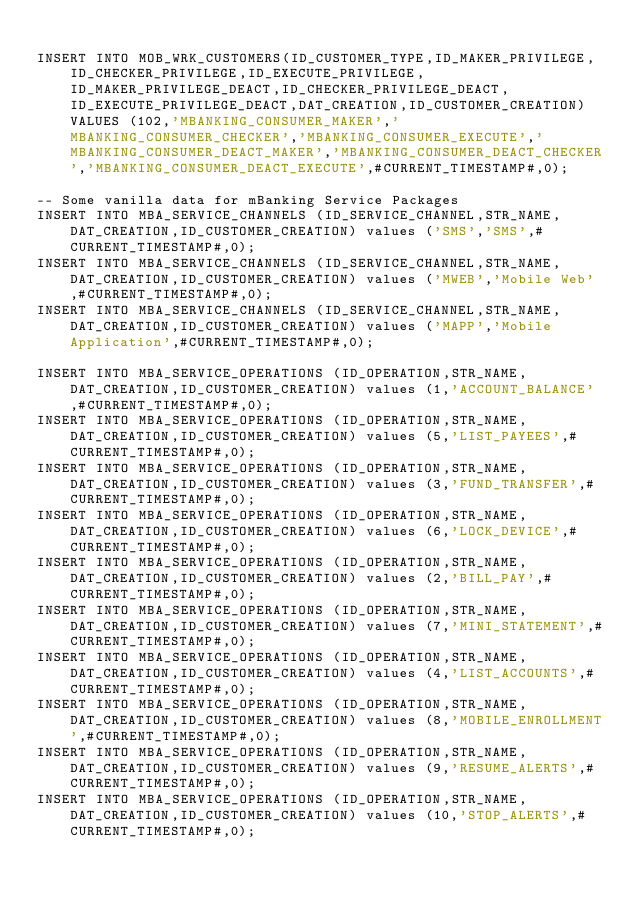Convert code to text. <code><loc_0><loc_0><loc_500><loc_500><_SQL_>
INSERT INTO MOB_WRK_CUSTOMERS(ID_CUSTOMER_TYPE,ID_MAKER_PRIVILEGE,ID_CHECKER_PRIVILEGE,ID_EXECUTE_PRIVILEGE,ID_MAKER_PRIVILEGE_DEACT,ID_CHECKER_PRIVILEGE_DEACT,ID_EXECUTE_PRIVILEGE_DEACT,DAT_CREATION,ID_CUSTOMER_CREATION) VALUES (102,'MBANKING_CONSUMER_MAKER','MBANKING_CONSUMER_CHECKER','MBANKING_CONSUMER_EXECUTE','MBANKING_CONSUMER_DEACT_MAKER','MBANKING_CONSUMER_DEACT_CHECKER','MBANKING_CONSUMER_DEACT_EXECUTE',#CURRENT_TIMESTAMP#,0);

-- Some vanilla data for mBanking Service Packages
INSERT INTO MBA_SERVICE_CHANNELS (ID_SERVICE_CHANNEL,STR_NAME,DAT_CREATION,ID_CUSTOMER_CREATION) values ('SMS','SMS',#CURRENT_TIMESTAMP#,0);
INSERT INTO MBA_SERVICE_CHANNELS (ID_SERVICE_CHANNEL,STR_NAME,DAT_CREATION,ID_CUSTOMER_CREATION) values ('MWEB','Mobile Web',#CURRENT_TIMESTAMP#,0);
INSERT INTO MBA_SERVICE_CHANNELS (ID_SERVICE_CHANNEL,STR_NAME,DAT_CREATION,ID_CUSTOMER_CREATION) values ('MAPP','Mobile Application',#CURRENT_TIMESTAMP#,0);

INSERT INTO MBA_SERVICE_OPERATIONS (ID_OPERATION,STR_NAME,DAT_CREATION,ID_CUSTOMER_CREATION) values (1,'ACCOUNT_BALANCE',#CURRENT_TIMESTAMP#,0);
INSERT INTO MBA_SERVICE_OPERATIONS (ID_OPERATION,STR_NAME,DAT_CREATION,ID_CUSTOMER_CREATION) values (5,'LIST_PAYEES',#CURRENT_TIMESTAMP#,0);
INSERT INTO MBA_SERVICE_OPERATIONS (ID_OPERATION,STR_NAME,DAT_CREATION,ID_CUSTOMER_CREATION) values (3,'FUND_TRANSFER',#CURRENT_TIMESTAMP#,0);
INSERT INTO MBA_SERVICE_OPERATIONS (ID_OPERATION,STR_NAME,DAT_CREATION,ID_CUSTOMER_CREATION) values (6,'LOCK_DEVICE',#CURRENT_TIMESTAMP#,0);
INSERT INTO MBA_SERVICE_OPERATIONS (ID_OPERATION,STR_NAME,DAT_CREATION,ID_CUSTOMER_CREATION) values (2,'BILL_PAY',#CURRENT_TIMESTAMP#,0);
INSERT INTO MBA_SERVICE_OPERATIONS (ID_OPERATION,STR_NAME,DAT_CREATION,ID_CUSTOMER_CREATION) values (7,'MINI_STATEMENT',#CURRENT_TIMESTAMP#,0);
INSERT INTO MBA_SERVICE_OPERATIONS (ID_OPERATION,STR_NAME,DAT_CREATION,ID_CUSTOMER_CREATION) values (4,'LIST_ACCOUNTS',#CURRENT_TIMESTAMP#,0);
INSERT INTO MBA_SERVICE_OPERATIONS (ID_OPERATION,STR_NAME,DAT_CREATION,ID_CUSTOMER_CREATION) values (8,'MOBILE_ENROLLMENT',#CURRENT_TIMESTAMP#,0);
INSERT INTO MBA_SERVICE_OPERATIONS (ID_OPERATION,STR_NAME,DAT_CREATION,ID_CUSTOMER_CREATION) values (9,'RESUME_ALERTS',#CURRENT_TIMESTAMP#,0);
INSERT INTO MBA_SERVICE_OPERATIONS (ID_OPERATION,STR_NAME,DAT_CREATION,ID_CUSTOMER_CREATION) values (10,'STOP_ALERTS',#CURRENT_TIMESTAMP#,0);</code> 